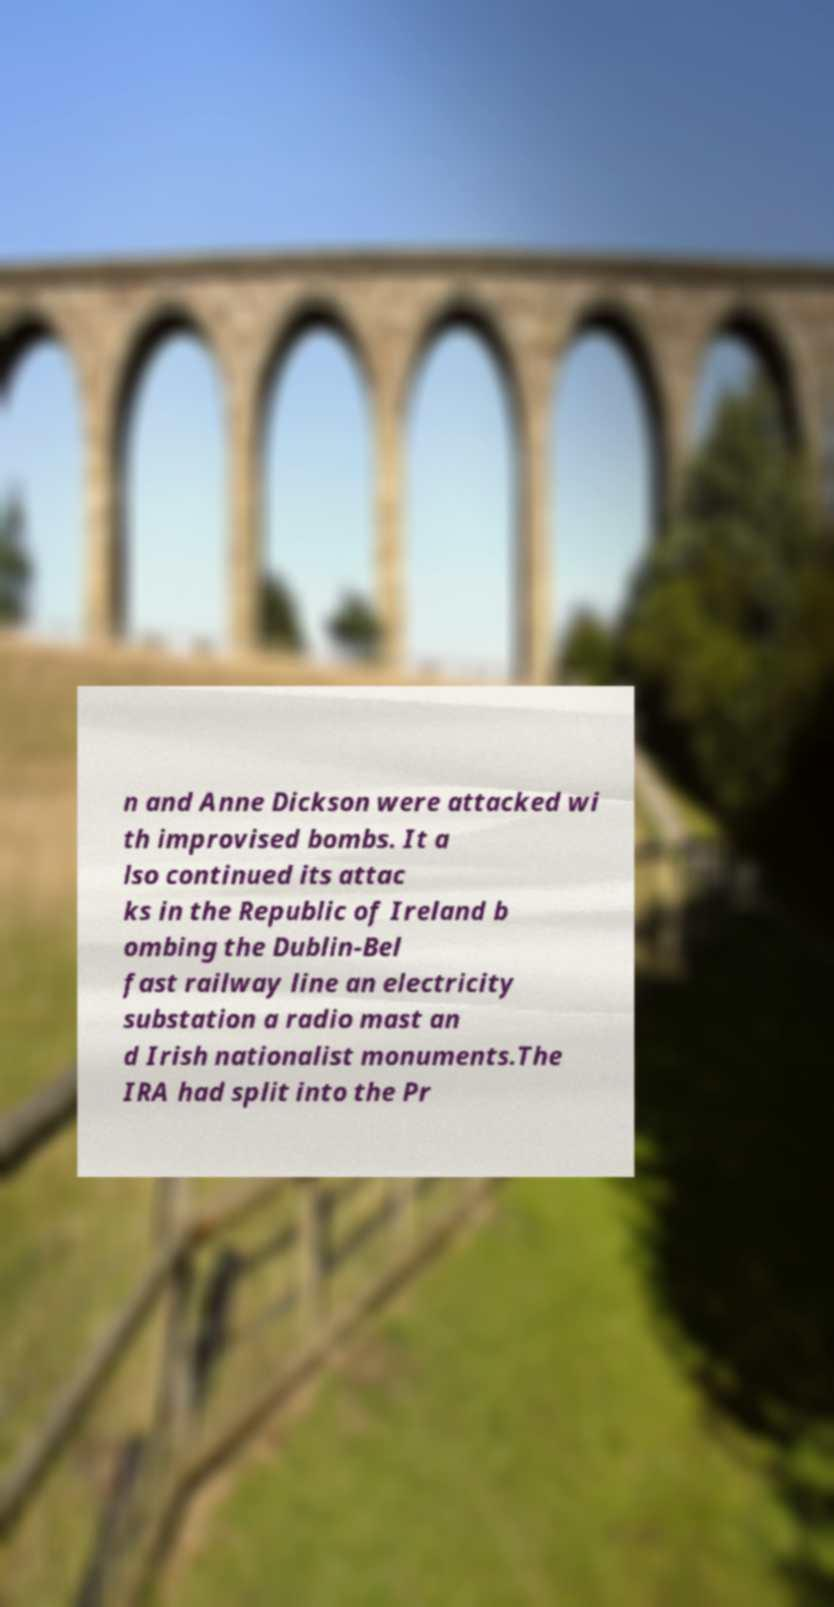Please identify and transcribe the text found in this image. n and Anne Dickson were attacked wi th improvised bombs. It a lso continued its attac ks in the Republic of Ireland b ombing the Dublin-Bel fast railway line an electricity substation a radio mast an d Irish nationalist monuments.The IRA had split into the Pr 